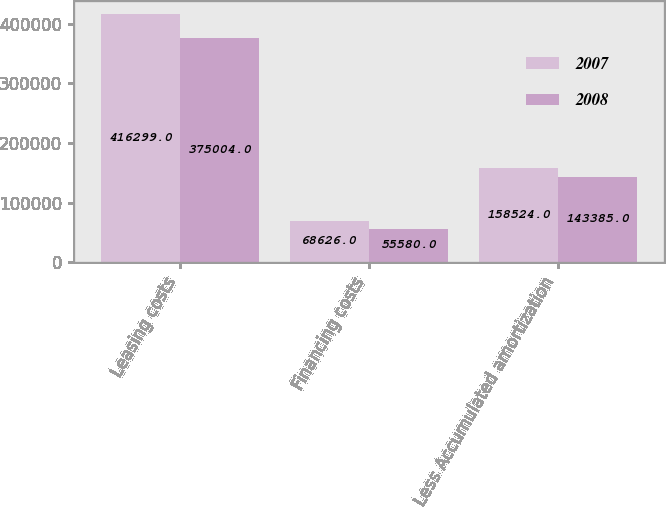<chart> <loc_0><loc_0><loc_500><loc_500><stacked_bar_chart><ecel><fcel>Leasing costs<fcel>Financing costs<fcel>Less Accumulated amortization<nl><fcel>2007<fcel>416299<fcel>68626<fcel>158524<nl><fcel>2008<fcel>375004<fcel>55580<fcel>143385<nl></chart> 